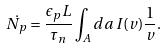Convert formula to latex. <formula><loc_0><loc_0><loc_500><loc_500>\dot { N _ { p } } = \frac { \epsilon _ { p } L } { \tau _ { n } } \int _ { A } d a \, I ( v ) \frac { 1 } { v } .</formula> 